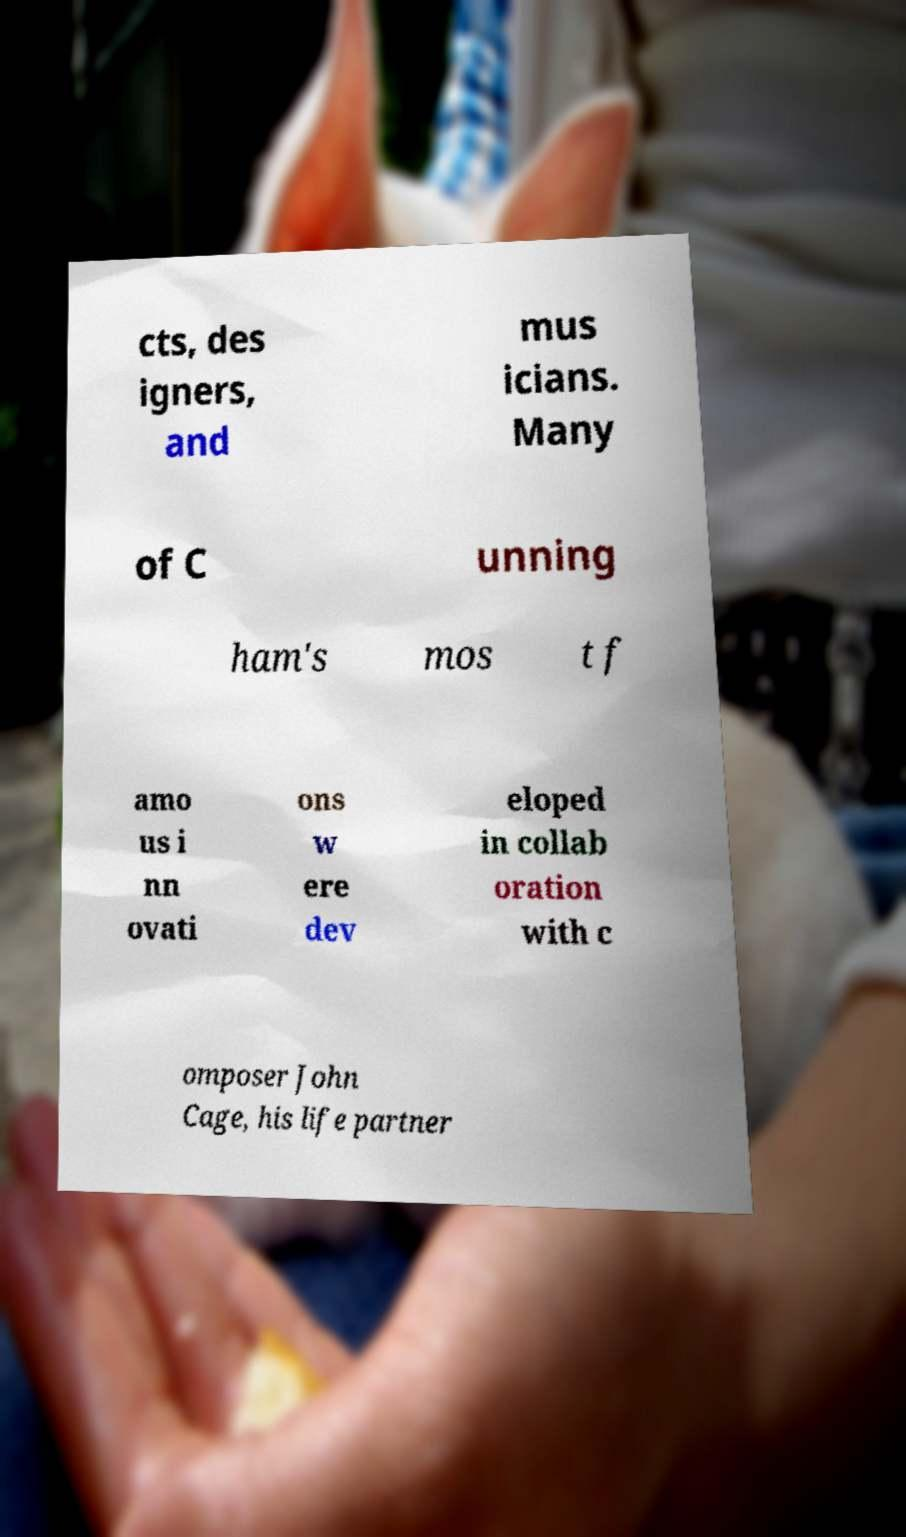Can you accurately transcribe the text from the provided image for me? cts, des igners, and mus icians. Many of C unning ham's mos t f amo us i nn ovati ons w ere dev eloped in collab oration with c omposer John Cage, his life partner 